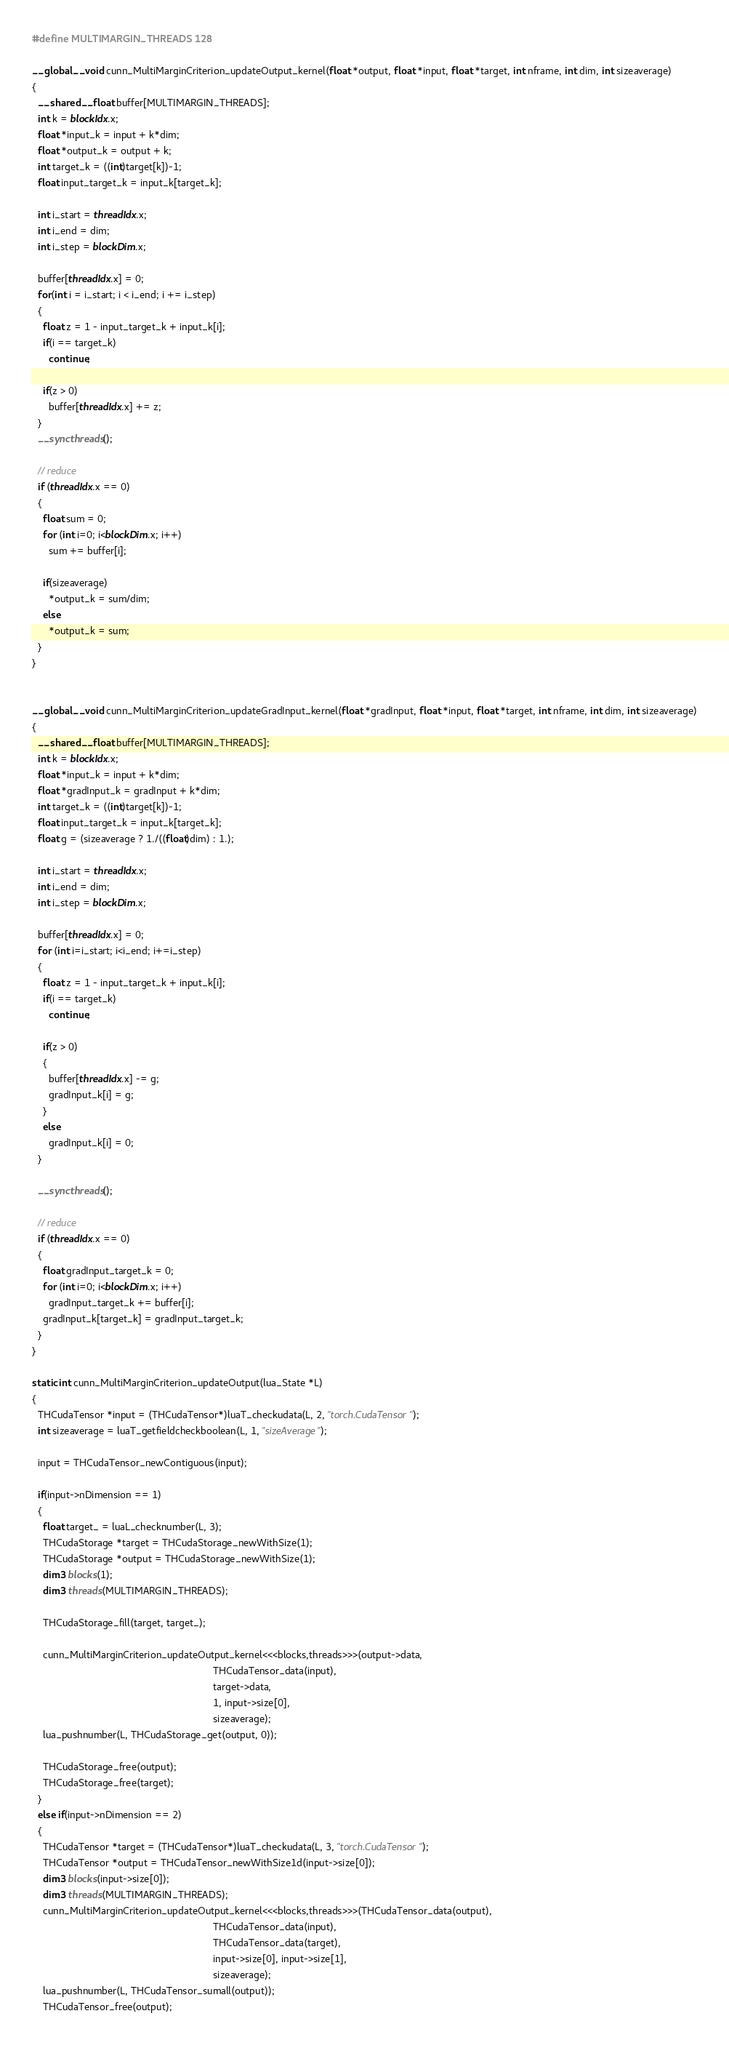<code> <loc_0><loc_0><loc_500><loc_500><_Cuda_>#define MULTIMARGIN_THREADS 128

__global__ void cunn_MultiMarginCriterion_updateOutput_kernel(float *output, float *input, float *target, int nframe, int dim, int sizeaverage)
{
  __shared__ float buffer[MULTIMARGIN_THREADS];
  int k = blockIdx.x;
  float *input_k = input + k*dim;
  float *output_k = output + k;
  int target_k = ((int)target[k])-1;
  float input_target_k = input_k[target_k];

  int i_start = threadIdx.x;
  int i_end = dim;
  int i_step = blockDim.x;

  buffer[threadIdx.x] = 0;
  for(int i = i_start; i < i_end; i += i_step)
  {
    float z = 1 - input_target_k + input_k[i];
    if(i == target_k)
      continue;
    
    if(z > 0)
      buffer[threadIdx.x] += z;
  }
  __syncthreads();

  // reduce
  if (threadIdx.x == 0)
  {
    float sum = 0;
    for (int i=0; i<blockDim.x; i++)
      sum += buffer[i];

    if(sizeaverage)
      *output_k = sum/dim;
    else
      *output_k = sum;
  }
}


__global__ void cunn_MultiMarginCriterion_updateGradInput_kernel(float *gradInput, float *input, float *target, int nframe, int dim, int sizeaverage)
{
  __shared__ float buffer[MULTIMARGIN_THREADS];
  int k = blockIdx.x;
  float *input_k = input + k*dim;
  float *gradInput_k = gradInput + k*dim;
  int target_k = ((int)target[k])-1;
  float input_target_k = input_k[target_k];
  float g = (sizeaverage ? 1./((float)dim) : 1.);

  int i_start = threadIdx.x;
  int i_end = dim;
  int i_step = blockDim.x;

  buffer[threadIdx.x] = 0;
  for (int i=i_start; i<i_end; i+=i_step)
  {
    float z = 1 - input_target_k + input_k[i];
    if(i == target_k)
      continue;
    
    if(z > 0)
    {
      buffer[threadIdx.x] -= g;
      gradInput_k[i] = g;
    }
    else
      gradInput_k[i] = 0;
  }

  __syncthreads();

  // reduce
  if (threadIdx.x == 0)
  {
    float gradInput_target_k = 0;
    for (int i=0; i<blockDim.x; i++)
      gradInput_target_k += buffer[i];
    gradInput_k[target_k] = gradInput_target_k;
  }
}

static int cunn_MultiMarginCriterion_updateOutput(lua_State *L)
{
  THCudaTensor *input = (THCudaTensor*)luaT_checkudata(L, 2, "torch.CudaTensor");
  int sizeaverage = luaT_getfieldcheckboolean(L, 1, "sizeAverage");

  input = THCudaTensor_newContiguous(input);

  if(input->nDimension == 1)
  {
    float target_ = luaL_checknumber(L, 3);
    THCudaStorage *target = THCudaStorage_newWithSize(1);
    THCudaStorage *output = THCudaStorage_newWithSize(1);
    dim3 blocks(1);
    dim3 threads(MULTIMARGIN_THREADS);

    THCudaStorage_fill(target, target_);

    cunn_MultiMarginCriterion_updateOutput_kernel<<<blocks,threads>>>(output->data,
                                                                 THCudaTensor_data(input),
                                                                 target->data,
                                                                 1, input->size[0],
                                                                 sizeaverage);
    lua_pushnumber(L, THCudaStorage_get(output, 0));

    THCudaStorage_free(output);
    THCudaStorage_free(target);
  }
  else if(input->nDimension == 2)
  {
    THCudaTensor *target = (THCudaTensor*)luaT_checkudata(L, 3, "torch.CudaTensor");
    THCudaTensor *output = THCudaTensor_newWithSize1d(input->size[0]);
    dim3 blocks(input->size[0]);
    dim3 threads(MULTIMARGIN_THREADS);
    cunn_MultiMarginCriterion_updateOutput_kernel<<<blocks,threads>>>(THCudaTensor_data(output),
                                                                 THCudaTensor_data(input),
                                                                 THCudaTensor_data(target),
                                                                 input->size[0], input->size[1],
                                                                 sizeaverage);
    lua_pushnumber(L, THCudaTensor_sumall(output));
    THCudaTensor_free(output);</code> 